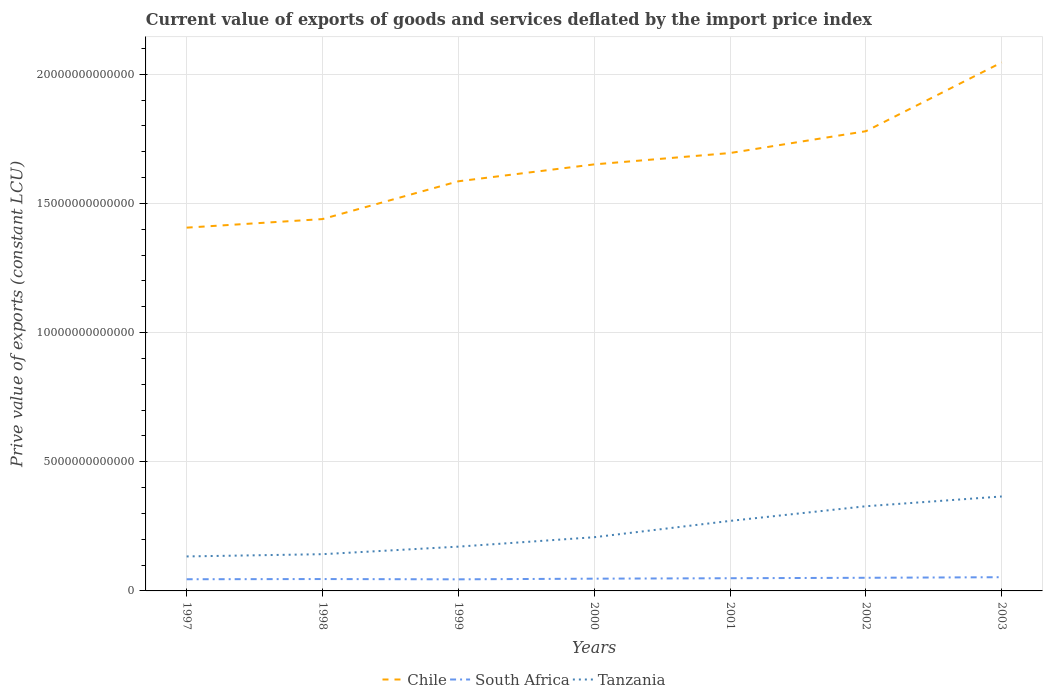Does the line corresponding to South Africa intersect with the line corresponding to Tanzania?
Your answer should be very brief. No. Across all years, what is the maximum prive value of exports in Chile?
Provide a succinct answer. 1.41e+13. In which year was the prive value of exports in South Africa maximum?
Make the answer very short. 1999. What is the total prive value of exports in Tanzania in the graph?
Your response must be concise. -1.86e+12. What is the difference between the highest and the second highest prive value of exports in Tanzania?
Your answer should be very brief. 2.32e+12. What is the difference between the highest and the lowest prive value of exports in Tanzania?
Offer a terse response. 3. Is the prive value of exports in Tanzania strictly greater than the prive value of exports in Chile over the years?
Give a very brief answer. Yes. What is the difference between two consecutive major ticks on the Y-axis?
Your answer should be compact. 5.00e+12. Does the graph contain any zero values?
Make the answer very short. No. Does the graph contain grids?
Provide a succinct answer. Yes. What is the title of the graph?
Your response must be concise. Current value of exports of goods and services deflated by the import price index. Does "South Africa" appear as one of the legend labels in the graph?
Make the answer very short. Yes. What is the label or title of the Y-axis?
Your answer should be very brief. Prive value of exports (constant LCU). What is the Prive value of exports (constant LCU) in Chile in 1997?
Your response must be concise. 1.41e+13. What is the Prive value of exports (constant LCU) of South Africa in 1997?
Give a very brief answer. 4.52e+11. What is the Prive value of exports (constant LCU) of Tanzania in 1997?
Keep it short and to the point. 1.34e+12. What is the Prive value of exports (constant LCU) of Chile in 1998?
Your answer should be compact. 1.44e+13. What is the Prive value of exports (constant LCU) in South Africa in 1998?
Your response must be concise. 4.60e+11. What is the Prive value of exports (constant LCU) in Tanzania in 1998?
Provide a succinct answer. 1.42e+12. What is the Prive value of exports (constant LCU) in Chile in 1999?
Offer a terse response. 1.59e+13. What is the Prive value of exports (constant LCU) of South Africa in 1999?
Offer a very short reply. 4.49e+11. What is the Prive value of exports (constant LCU) in Tanzania in 1999?
Your answer should be very brief. 1.71e+12. What is the Prive value of exports (constant LCU) of Chile in 2000?
Your answer should be compact. 1.65e+13. What is the Prive value of exports (constant LCU) in South Africa in 2000?
Ensure brevity in your answer.  4.75e+11. What is the Prive value of exports (constant LCU) in Tanzania in 2000?
Your answer should be compact. 2.08e+12. What is the Prive value of exports (constant LCU) in Chile in 2001?
Give a very brief answer. 1.70e+13. What is the Prive value of exports (constant LCU) in South Africa in 2001?
Ensure brevity in your answer.  4.91e+11. What is the Prive value of exports (constant LCU) in Tanzania in 2001?
Ensure brevity in your answer.  2.71e+12. What is the Prive value of exports (constant LCU) in Chile in 2002?
Make the answer very short. 1.78e+13. What is the Prive value of exports (constant LCU) of South Africa in 2002?
Make the answer very short. 5.09e+11. What is the Prive value of exports (constant LCU) in Tanzania in 2002?
Ensure brevity in your answer.  3.28e+12. What is the Prive value of exports (constant LCU) of Chile in 2003?
Provide a short and direct response. 2.05e+13. What is the Prive value of exports (constant LCU) in South Africa in 2003?
Offer a very short reply. 5.31e+11. What is the Prive value of exports (constant LCU) of Tanzania in 2003?
Your answer should be compact. 3.66e+12. Across all years, what is the maximum Prive value of exports (constant LCU) of Chile?
Make the answer very short. 2.05e+13. Across all years, what is the maximum Prive value of exports (constant LCU) in South Africa?
Ensure brevity in your answer.  5.31e+11. Across all years, what is the maximum Prive value of exports (constant LCU) in Tanzania?
Your answer should be compact. 3.66e+12. Across all years, what is the minimum Prive value of exports (constant LCU) of Chile?
Offer a very short reply. 1.41e+13. Across all years, what is the minimum Prive value of exports (constant LCU) in South Africa?
Provide a short and direct response. 4.49e+11. Across all years, what is the minimum Prive value of exports (constant LCU) of Tanzania?
Make the answer very short. 1.34e+12. What is the total Prive value of exports (constant LCU) in Chile in the graph?
Make the answer very short. 1.16e+14. What is the total Prive value of exports (constant LCU) of South Africa in the graph?
Provide a short and direct response. 3.37e+12. What is the total Prive value of exports (constant LCU) of Tanzania in the graph?
Offer a very short reply. 1.62e+13. What is the difference between the Prive value of exports (constant LCU) in Chile in 1997 and that in 1998?
Provide a short and direct response. -3.32e+11. What is the difference between the Prive value of exports (constant LCU) in South Africa in 1997 and that in 1998?
Offer a very short reply. -7.87e+09. What is the difference between the Prive value of exports (constant LCU) in Tanzania in 1997 and that in 1998?
Provide a short and direct response. -8.70e+1. What is the difference between the Prive value of exports (constant LCU) in Chile in 1997 and that in 1999?
Provide a succinct answer. -1.79e+12. What is the difference between the Prive value of exports (constant LCU) in South Africa in 1997 and that in 1999?
Keep it short and to the point. 3.42e+09. What is the difference between the Prive value of exports (constant LCU) in Tanzania in 1997 and that in 1999?
Your response must be concise. -3.79e+11. What is the difference between the Prive value of exports (constant LCU) in Chile in 1997 and that in 2000?
Make the answer very short. -2.45e+12. What is the difference between the Prive value of exports (constant LCU) in South Africa in 1997 and that in 2000?
Make the answer very short. -2.25e+1. What is the difference between the Prive value of exports (constant LCU) of Tanzania in 1997 and that in 2000?
Ensure brevity in your answer.  -7.44e+11. What is the difference between the Prive value of exports (constant LCU) in Chile in 1997 and that in 2001?
Ensure brevity in your answer.  -2.89e+12. What is the difference between the Prive value of exports (constant LCU) of South Africa in 1997 and that in 2001?
Make the answer very short. -3.92e+1. What is the difference between the Prive value of exports (constant LCU) in Tanzania in 1997 and that in 2001?
Ensure brevity in your answer.  -1.38e+12. What is the difference between the Prive value of exports (constant LCU) of Chile in 1997 and that in 2002?
Offer a terse response. -3.73e+12. What is the difference between the Prive value of exports (constant LCU) in South Africa in 1997 and that in 2002?
Your answer should be compact. -5.67e+1. What is the difference between the Prive value of exports (constant LCU) in Tanzania in 1997 and that in 2002?
Keep it short and to the point. -1.94e+12. What is the difference between the Prive value of exports (constant LCU) of Chile in 1997 and that in 2003?
Your answer should be very brief. -6.40e+12. What is the difference between the Prive value of exports (constant LCU) in South Africa in 1997 and that in 2003?
Ensure brevity in your answer.  -7.89e+1. What is the difference between the Prive value of exports (constant LCU) in Tanzania in 1997 and that in 2003?
Provide a succinct answer. -2.32e+12. What is the difference between the Prive value of exports (constant LCU) of Chile in 1998 and that in 1999?
Offer a very short reply. -1.46e+12. What is the difference between the Prive value of exports (constant LCU) in South Africa in 1998 and that in 1999?
Offer a very short reply. 1.13e+1. What is the difference between the Prive value of exports (constant LCU) in Tanzania in 1998 and that in 1999?
Your answer should be very brief. -2.92e+11. What is the difference between the Prive value of exports (constant LCU) of Chile in 1998 and that in 2000?
Your answer should be very brief. -2.12e+12. What is the difference between the Prive value of exports (constant LCU) of South Africa in 1998 and that in 2000?
Offer a terse response. -1.46e+1. What is the difference between the Prive value of exports (constant LCU) of Tanzania in 1998 and that in 2000?
Offer a very short reply. -6.57e+11. What is the difference between the Prive value of exports (constant LCU) in Chile in 1998 and that in 2001?
Provide a short and direct response. -2.56e+12. What is the difference between the Prive value of exports (constant LCU) in South Africa in 1998 and that in 2001?
Your response must be concise. -3.14e+1. What is the difference between the Prive value of exports (constant LCU) of Tanzania in 1998 and that in 2001?
Provide a succinct answer. -1.29e+12. What is the difference between the Prive value of exports (constant LCU) in Chile in 1998 and that in 2002?
Ensure brevity in your answer.  -3.40e+12. What is the difference between the Prive value of exports (constant LCU) of South Africa in 1998 and that in 2002?
Offer a very short reply. -4.88e+1. What is the difference between the Prive value of exports (constant LCU) in Tanzania in 1998 and that in 2002?
Your response must be concise. -1.86e+12. What is the difference between the Prive value of exports (constant LCU) of Chile in 1998 and that in 2003?
Ensure brevity in your answer.  -6.06e+12. What is the difference between the Prive value of exports (constant LCU) in South Africa in 1998 and that in 2003?
Provide a short and direct response. -7.10e+1. What is the difference between the Prive value of exports (constant LCU) in Tanzania in 1998 and that in 2003?
Ensure brevity in your answer.  -2.23e+12. What is the difference between the Prive value of exports (constant LCU) in Chile in 1999 and that in 2000?
Offer a very short reply. -6.54e+11. What is the difference between the Prive value of exports (constant LCU) of South Africa in 1999 and that in 2000?
Keep it short and to the point. -2.59e+1. What is the difference between the Prive value of exports (constant LCU) of Tanzania in 1999 and that in 2000?
Your answer should be compact. -3.65e+11. What is the difference between the Prive value of exports (constant LCU) of Chile in 1999 and that in 2001?
Provide a short and direct response. -1.09e+12. What is the difference between the Prive value of exports (constant LCU) in South Africa in 1999 and that in 2001?
Ensure brevity in your answer.  -4.26e+1. What is the difference between the Prive value of exports (constant LCU) in Tanzania in 1999 and that in 2001?
Your answer should be very brief. -9.97e+11. What is the difference between the Prive value of exports (constant LCU) of Chile in 1999 and that in 2002?
Ensure brevity in your answer.  -1.94e+12. What is the difference between the Prive value of exports (constant LCU) in South Africa in 1999 and that in 2002?
Your answer should be very brief. -6.01e+1. What is the difference between the Prive value of exports (constant LCU) in Tanzania in 1999 and that in 2002?
Provide a succinct answer. -1.56e+12. What is the difference between the Prive value of exports (constant LCU) in Chile in 1999 and that in 2003?
Give a very brief answer. -4.60e+12. What is the difference between the Prive value of exports (constant LCU) of South Africa in 1999 and that in 2003?
Give a very brief answer. -8.23e+1. What is the difference between the Prive value of exports (constant LCU) of Tanzania in 1999 and that in 2003?
Offer a terse response. -1.94e+12. What is the difference between the Prive value of exports (constant LCU) of Chile in 2000 and that in 2001?
Make the answer very short. -4.39e+11. What is the difference between the Prive value of exports (constant LCU) in South Africa in 2000 and that in 2001?
Your response must be concise. -1.68e+1. What is the difference between the Prive value of exports (constant LCU) of Tanzania in 2000 and that in 2001?
Your answer should be compact. -6.32e+11. What is the difference between the Prive value of exports (constant LCU) of Chile in 2000 and that in 2002?
Your response must be concise. -1.28e+12. What is the difference between the Prive value of exports (constant LCU) of South Africa in 2000 and that in 2002?
Make the answer very short. -3.42e+1. What is the difference between the Prive value of exports (constant LCU) of Tanzania in 2000 and that in 2002?
Offer a terse response. -1.20e+12. What is the difference between the Prive value of exports (constant LCU) in Chile in 2000 and that in 2003?
Your answer should be very brief. -3.95e+12. What is the difference between the Prive value of exports (constant LCU) of South Africa in 2000 and that in 2003?
Your response must be concise. -5.64e+1. What is the difference between the Prive value of exports (constant LCU) in Tanzania in 2000 and that in 2003?
Your response must be concise. -1.58e+12. What is the difference between the Prive value of exports (constant LCU) of Chile in 2001 and that in 2002?
Your answer should be compact. -8.45e+11. What is the difference between the Prive value of exports (constant LCU) in South Africa in 2001 and that in 2002?
Make the answer very short. -1.75e+1. What is the difference between the Prive value of exports (constant LCU) of Tanzania in 2001 and that in 2002?
Your response must be concise. -5.68e+11. What is the difference between the Prive value of exports (constant LCU) in Chile in 2001 and that in 2003?
Provide a succinct answer. -3.51e+12. What is the difference between the Prive value of exports (constant LCU) of South Africa in 2001 and that in 2003?
Your answer should be compact. -3.97e+1. What is the difference between the Prive value of exports (constant LCU) in Tanzania in 2001 and that in 2003?
Offer a terse response. -9.46e+11. What is the difference between the Prive value of exports (constant LCU) in Chile in 2002 and that in 2003?
Offer a very short reply. -2.66e+12. What is the difference between the Prive value of exports (constant LCU) of South Africa in 2002 and that in 2003?
Your answer should be very brief. -2.22e+1. What is the difference between the Prive value of exports (constant LCU) of Tanzania in 2002 and that in 2003?
Keep it short and to the point. -3.78e+11. What is the difference between the Prive value of exports (constant LCU) of Chile in 1997 and the Prive value of exports (constant LCU) of South Africa in 1998?
Provide a short and direct response. 1.36e+13. What is the difference between the Prive value of exports (constant LCU) of Chile in 1997 and the Prive value of exports (constant LCU) of Tanzania in 1998?
Ensure brevity in your answer.  1.26e+13. What is the difference between the Prive value of exports (constant LCU) in South Africa in 1997 and the Prive value of exports (constant LCU) in Tanzania in 1998?
Your response must be concise. -9.70e+11. What is the difference between the Prive value of exports (constant LCU) of Chile in 1997 and the Prive value of exports (constant LCU) of South Africa in 1999?
Keep it short and to the point. 1.36e+13. What is the difference between the Prive value of exports (constant LCU) in Chile in 1997 and the Prive value of exports (constant LCU) in Tanzania in 1999?
Make the answer very short. 1.23e+13. What is the difference between the Prive value of exports (constant LCU) in South Africa in 1997 and the Prive value of exports (constant LCU) in Tanzania in 1999?
Your answer should be compact. -1.26e+12. What is the difference between the Prive value of exports (constant LCU) in Chile in 1997 and the Prive value of exports (constant LCU) in South Africa in 2000?
Ensure brevity in your answer.  1.36e+13. What is the difference between the Prive value of exports (constant LCU) of Chile in 1997 and the Prive value of exports (constant LCU) of Tanzania in 2000?
Make the answer very short. 1.20e+13. What is the difference between the Prive value of exports (constant LCU) in South Africa in 1997 and the Prive value of exports (constant LCU) in Tanzania in 2000?
Give a very brief answer. -1.63e+12. What is the difference between the Prive value of exports (constant LCU) in Chile in 1997 and the Prive value of exports (constant LCU) in South Africa in 2001?
Offer a terse response. 1.36e+13. What is the difference between the Prive value of exports (constant LCU) in Chile in 1997 and the Prive value of exports (constant LCU) in Tanzania in 2001?
Provide a succinct answer. 1.14e+13. What is the difference between the Prive value of exports (constant LCU) in South Africa in 1997 and the Prive value of exports (constant LCU) in Tanzania in 2001?
Your answer should be compact. -2.26e+12. What is the difference between the Prive value of exports (constant LCU) in Chile in 1997 and the Prive value of exports (constant LCU) in South Africa in 2002?
Your answer should be very brief. 1.36e+13. What is the difference between the Prive value of exports (constant LCU) in Chile in 1997 and the Prive value of exports (constant LCU) in Tanzania in 2002?
Ensure brevity in your answer.  1.08e+13. What is the difference between the Prive value of exports (constant LCU) of South Africa in 1997 and the Prive value of exports (constant LCU) of Tanzania in 2002?
Your answer should be compact. -2.83e+12. What is the difference between the Prive value of exports (constant LCU) in Chile in 1997 and the Prive value of exports (constant LCU) in South Africa in 2003?
Keep it short and to the point. 1.35e+13. What is the difference between the Prive value of exports (constant LCU) in Chile in 1997 and the Prive value of exports (constant LCU) in Tanzania in 2003?
Make the answer very short. 1.04e+13. What is the difference between the Prive value of exports (constant LCU) of South Africa in 1997 and the Prive value of exports (constant LCU) of Tanzania in 2003?
Make the answer very short. -3.20e+12. What is the difference between the Prive value of exports (constant LCU) of Chile in 1998 and the Prive value of exports (constant LCU) of South Africa in 1999?
Make the answer very short. 1.39e+13. What is the difference between the Prive value of exports (constant LCU) in Chile in 1998 and the Prive value of exports (constant LCU) in Tanzania in 1999?
Offer a very short reply. 1.27e+13. What is the difference between the Prive value of exports (constant LCU) of South Africa in 1998 and the Prive value of exports (constant LCU) of Tanzania in 1999?
Make the answer very short. -1.25e+12. What is the difference between the Prive value of exports (constant LCU) of Chile in 1998 and the Prive value of exports (constant LCU) of South Africa in 2000?
Your response must be concise. 1.39e+13. What is the difference between the Prive value of exports (constant LCU) in Chile in 1998 and the Prive value of exports (constant LCU) in Tanzania in 2000?
Offer a very short reply. 1.23e+13. What is the difference between the Prive value of exports (constant LCU) of South Africa in 1998 and the Prive value of exports (constant LCU) of Tanzania in 2000?
Your answer should be compact. -1.62e+12. What is the difference between the Prive value of exports (constant LCU) in Chile in 1998 and the Prive value of exports (constant LCU) in South Africa in 2001?
Give a very brief answer. 1.39e+13. What is the difference between the Prive value of exports (constant LCU) of Chile in 1998 and the Prive value of exports (constant LCU) of Tanzania in 2001?
Provide a short and direct response. 1.17e+13. What is the difference between the Prive value of exports (constant LCU) in South Africa in 1998 and the Prive value of exports (constant LCU) in Tanzania in 2001?
Give a very brief answer. -2.25e+12. What is the difference between the Prive value of exports (constant LCU) of Chile in 1998 and the Prive value of exports (constant LCU) of South Africa in 2002?
Offer a very short reply. 1.39e+13. What is the difference between the Prive value of exports (constant LCU) in Chile in 1998 and the Prive value of exports (constant LCU) in Tanzania in 2002?
Your answer should be very brief. 1.11e+13. What is the difference between the Prive value of exports (constant LCU) in South Africa in 1998 and the Prive value of exports (constant LCU) in Tanzania in 2002?
Provide a succinct answer. -2.82e+12. What is the difference between the Prive value of exports (constant LCU) in Chile in 1998 and the Prive value of exports (constant LCU) in South Africa in 2003?
Your answer should be compact. 1.39e+13. What is the difference between the Prive value of exports (constant LCU) of Chile in 1998 and the Prive value of exports (constant LCU) of Tanzania in 2003?
Provide a short and direct response. 1.07e+13. What is the difference between the Prive value of exports (constant LCU) in South Africa in 1998 and the Prive value of exports (constant LCU) in Tanzania in 2003?
Make the answer very short. -3.20e+12. What is the difference between the Prive value of exports (constant LCU) in Chile in 1999 and the Prive value of exports (constant LCU) in South Africa in 2000?
Your answer should be very brief. 1.54e+13. What is the difference between the Prive value of exports (constant LCU) of Chile in 1999 and the Prive value of exports (constant LCU) of Tanzania in 2000?
Keep it short and to the point. 1.38e+13. What is the difference between the Prive value of exports (constant LCU) in South Africa in 1999 and the Prive value of exports (constant LCU) in Tanzania in 2000?
Ensure brevity in your answer.  -1.63e+12. What is the difference between the Prive value of exports (constant LCU) of Chile in 1999 and the Prive value of exports (constant LCU) of South Africa in 2001?
Provide a succinct answer. 1.54e+13. What is the difference between the Prive value of exports (constant LCU) of Chile in 1999 and the Prive value of exports (constant LCU) of Tanzania in 2001?
Provide a short and direct response. 1.31e+13. What is the difference between the Prive value of exports (constant LCU) of South Africa in 1999 and the Prive value of exports (constant LCU) of Tanzania in 2001?
Your answer should be compact. -2.26e+12. What is the difference between the Prive value of exports (constant LCU) of Chile in 1999 and the Prive value of exports (constant LCU) of South Africa in 2002?
Keep it short and to the point. 1.53e+13. What is the difference between the Prive value of exports (constant LCU) of Chile in 1999 and the Prive value of exports (constant LCU) of Tanzania in 2002?
Your response must be concise. 1.26e+13. What is the difference between the Prive value of exports (constant LCU) in South Africa in 1999 and the Prive value of exports (constant LCU) in Tanzania in 2002?
Offer a very short reply. -2.83e+12. What is the difference between the Prive value of exports (constant LCU) of Chile in 1999 and the Prive value of exports (constant LCU) of South Africa in 2003?
Keep it short and to the point. 1.53e+13. What is the difference between the Prive value of exports (constant LCU) in Chile in 1999 and the Prive value of exports (constant LCU) in Tanzania in 2003?
Offer a terse response. 1.22e+13. What is the difference between the Prive value of exports (constant LCU) in South Africa in 1999 and the Prive value of exports (constant LCU) in Tanzania in 2003?
Provide a succinct answer. -3.21e+12. What is the difference between the Prive value of exports (constant LCU) of Chile in 2000 and the Prive value of exports (constant LCU) of South Africa in 2001?
Provide a succinct answer. 1.60e+13. What is the difference between the Prive value of exports (constant LCU) of Chile in 2000 and the Prive value of exports (constant LCU) of Tanzania in 2001?
Offer a very short reply. 1.38e+13. What is the difference between the Prive value of exports (constant LCU) in South Africa in 2000 and the Prive value of exports (constant LCU) in Tanzania in 2001?
Give a very brief answer. -2.24e+12. What is the difference between the Prive value of exports (constant LCU) in Chile in 2000 and the Prive value of exports (constant LCU) in South Africa in 2002?
Your answer should be compact. 1.60e+13. What is the difference between the Prive value of exports (constant LCU) of Chile in 2000 and the Prive value of exports (constant LCU) of Tanzania in 2002?
Your answer should be very brief. 1.32e+13. What is the difference between the Prive value of exports (constant LCU) in South Africa in 2000 and the Prive value of exports (constant LCU) in Tanzania in 2002?
Offer a terse response. -2.80e+12. What is the difference between the Prive value of exports (constant LCU) of Chile in 2000 and the Prive value of exports (constant LCU) of South Africa in 2003?
Provide a succinct answer. 1.60e+13. What is the difference between the Prive value of exports (constant LCU) in Chile in 2000 and the Prive value of exports (constant LCU) in Tanzania in 2003?
Make the answer very short. 1.29e+13. What is the difference between the Prive value of exports (constant LCU) of South Africa in 2000 and the Prive value of exports (constant LCU) of Tanzania in 2003?
Make the answer very short. -3.18e+12. What is the difference between the Prive value of exports (constant LCU) of Chile in 2001 and the Prive value of exports (constant LCU) of South Africa in 2002?
Your answer should be compact. 1.64e+13. What is the difference between the Prive value of exports (constant LCU) of Chile in 2001 and the Prive value of exports (constant LCU) of Tanzania in 2002?
Ensure brevity in your answer.  1.37e+13. What is the difference between the Prive value of exports (constant LCU) of South Africa in 2001 and the Prive value of exports (constant LCU) of Tanzania in 2002?
Ensure brevity in your answer.  -2.79e+12. What is the difference between the Prive value of exports (constant LCU) of Chile in 2001 and the Prive value of exports (constant LCU) of South Africa in 2003?
Provide a short and direct response. 1.64e+13. What is the difference between the Prive value of exports (constant LCU) of Chile in 2001 and the Prive value of exports (constant LCU) of Tanzania in 2003?
Your answer should be compact. 1.33e+13. What is the difference between the Prive value of exports (constant LCU) in South Africa in 2001 and the Prive value of exports (constant LCU) in Tanzania in 2003?
Your response must be concise. -3.17e+12. What is the difference between the Prive value of exports (constant LCU) in Chile in 2002 and the Prive value of exports (constant LCU) in South Africa in 2003?
Offer a very short reply. 1.73e+13. What is the difference between the Prive value of exports (constant LCU) of Chile in 2002 and the Prive value of exports (constant LCU) of Tanzania in 2003?
Provide a succinct answer. 1.41e+13. What is the difference between the Prive value of exports (constant LCU) in South Africa in 2002 and the Prive value of exports (constant LCU) in Tanzania in 2003?
Provide a succinct answer. -3.15e+12. What is the average Prive value of exports (constant LCU) of Chile per year?
Keep it short and to the point. 1.66e+13. What is the average Prive value of exports (constant LCU) in South Africa per year?
Make the answer very short. 4.81e+11. What is the average Prive value of exports (constant LCU) in Tanzania per year?
Ensure brevity in your answer.  2.31e+12. In the year 1997, what is the difference between the Prive value of exports (constant LCU) of Chile and Prive value of exports (constant LCU) of South Africa?
Keep it short and to the point. 1.36e+13. In the year 1997, what is the difference between the Prive value of exports (constant LCU) in Chile and Prive value of exports (constant LCU) in Tanzania?
Give a very brief answer. 1.27e+13. In the year 1997, what is the difference between the Prive value of exports (constant LCU) of South Africa and Prive value of exports (constant LCU) of Tanzania?
Provide a succinct answer. -8.83e+11. In the year 1998, what is the difference between the Prive value of exports (constant LCU) in Chile and Prive value of exports (constant LCU) in South Africa?
Make the answer very short. 1.39e+13. In the year 1998, what is the difference between the Prive value of exports (constant LCU) in Chile and Prive value of exports (constant LCU) in Tanzania?
Offer a terse response. 1.30e+13. In the year 1998, what is the difference between the Prive value of exports (constant LCU) of South Africa and Prive value of exports (constant LCU) of Tanzania?
Give a very brief answer. -9.62e+11. In the year 1999, what is the difference between the Prive value of exports (constant LCU) in Chile and Prive value of exports (constant LCU) in South Africa?
Your response must be concise. 1.54e+13. In the year 1999, what is the difference between the Prive value of exports (constant LCU) of Chile and Prive value of exports (constant LCU) of Tanzania?
Your response must be concise. 1.41e+13. In the year 1999, what is the difference between the Prive value of exports (constant LCU) in South Africa and Prive value of exports (constant LCU) in Tanzania?
Your answer should be very brief. -1.27e+12. In the year 2000, what is the difference between the Prive value of exports (constant LCU) in Chile and Prive value of exports (constant LCU) in South Africa?
Provide a short and direct response. 1.60e+13. In the year 2000, what is the difference between the Prive value of exports (constant LCU) of Chile and Prive value of exports (constant LCU) of Tanzania?
Make the answer very short. 1.44e+13. In the year 2000, what is the difference between the Prive value of exports (constant LCU) in South Africa and Prive value of exports (constant LCU) in Tanzania?
Your answer should be very brief. -1.60e+12. In the year 2001, what is the difference between the Prive value of exports (constant LCU) in Chile and Prive value of exports (constant LCU) in South Africa?
Your answer should be very brief. 1.65e+13. In the year 2001, what is the difference between the Prive value of exports (constant LCU) in Chile and Prive value of exports (constant LCU) in Tanzania?
Ensure brevity in your answer.  1.42e+13. In the year 2001, what is the difference between the Prive value of exports (constant LCU) in South Africa and Prive value of exports (constant LCU) in Tanzania?
Provide a short and direct response. -2.22e+12. In the year 2002, what is the difference between the Prive value of exports (constant LCU) of Chile and Prive value of exports (constant LCU) of South Africa?
Offer a very short reply. 1.73e+13. In the year 2002, what is the difference between the Prive value of exports (constant LCU) in Chile and Prive value of exports (constant LCU) in Tanzania?
Offer a very short reply. 1.45e+13. In the year 2002, what is the difference between the Prive value of exports (constant LCU) in South Africa and Prive value of exports (constant LCU) in Tanzania?
Provide a succinct answer. -2.77e+12. In the year 2003, what is the difference between the Prive value of exports (constant LCU) of Chile and Prive value of exports (constant LCU) of South Africa?
Your answer should be very brief. 1.99e+13. In the year 2003, what is the difference between the Prive value of exports (constant LCU) of Chile and Prive value of exports (constant LCU) of Tanzania?
Make the answer very short. 1.68e+13. In the year 2003, what is the difference between the Prive value of exports (constant LCU) in South Africa and Prive value of exports (constant LCU) in Tanzania?
Provide a short and direct response. -3.13e+12. What is the ratio of the Prive value of exports (constant LCU) of Chile in 1997 to that in 1998?
Your response must be concise. 0.98. What is the ratio of the Prive value of exports (constant LCU) in South Africa in 1997 to that in 1998?
Your answer should be compact. 0.98. What is the ratio of the Prive value of exports (constant LCU) of Tanzania in 1997 to that in 1998?
Your answer should be very brief. 0.94. What is the ratio of the Prive value of exports (constant LCU) of Chile in 1997 to that in 1999?
Give a very brief answer. 0.89. What is the ratio of the Prive value of exports (constant LCU) in South Africa in 1997 to that in 1999?
Provide a short and direct response. 1.01. What is the ratio of the Prive value of exports (constant LCU) of Tanzania in 1997 to that in 1999?
Keep it short and to the point. 0.78. What is the ratio of the Prive value of exports (constant LCU) in Chile in 1997 to that in 2000?
Your answer should be compact. 0.85. What is the ratio of the Prive value of exports (constant LCU) in South Africa in 1997 to that in 2000?
Ensure brevity in your answer.  0.95. What is the ratio of the Prive value of exports (constant LCU) of Tanzania in 1997 to that in 2000?
Offer a terse response. 0.64. What is the ratio of the Prive value of exports (constant LCU) of Chile in 1997 to that in 2001?
Your response must be concise. 0.83. What is the ratio of the Prive value of exports (constant LCU) in South Africa in 1997 to that in 2001?
Offer a very short reply. 0.92. What is the ratio of the Prive value of exports (constant LCU) in Tanzania in 1997 to that in 2001?
Provide a succinct answer. 0.49. What is the ratio of the Prive value of exports (constant LCU) of Chile in 1997 to that in 2002?
Make the answer very short. 0.79. What is the ratio of the Prive value of exports (constant LCU) in South Africa in 1997 to that in 2002?
Offer a terse response. 0.89. What is the ratio of the Prive value of exports (constant LCU) in Tanzania in 1997 to that in 2002?
Your answer should be compact. 0.41. What is the ratio of the Prive value of exports (constant LCU) of Chile in 1997 to that in 2003?
Make the answer very short. 0.69. What is the ratio of the Prive value of exports (constant LCU) in South Africa in 1997 to that in 2003?
Provide a short and direct response. 0.85. What is the ratio of the Prive value of exports (constant LCU) of Tanzania in 1997 to that in 2003?
Provide a succinct answer. 0.37. What is the ratio of the Prive value of exports (constant LCU) of Chile in 1998 to that in 1999?
Your response must be concise. 0.91. What is the ratio of the Prive value of exports (constant LCU) of South Africa in 1998 to that in 1999?
Make the answer very short. 1.03. What is the ratio of the Prive value of exports (constant LCU) in Tanzania in 1998 to that in 1999?
Offer a very short reply. 0.83. What is the ratio of the Prive value of exports (constant LCU) in Chile in 1998 to that in 2000?
Make the answer very short. 0.87. What is the ratio of the Prive value of exports (constant LCU) of South Africa in 1998 to that in 2000?
Your answer should be compact. 0.97. What is the ratio of the Prive value of exports (constant LCU) in Tanzania in 1998 to that in 2000?
Keep it short and to the point. 0.68. What is the ratio of the Prive value of exports (constant LCU) of Chile in 1998 to that in 2001?
Your answer should be very brief. 0.85. What is the ratio of the Prive value of exports (constant LCU) of South Africa in 1998 to that in 2001?
Ensure brevity in your answer.  0.94. What is the ratio of the Prive value of exports (constant LCU) in Tanzania in 1998 to that in 2001?
Provide a short and direct response. 0.52. What is the ratio of the Prive value of exports (constant LCU) of Chile in 1998 to that in 2002?
Keep it short and to the point. 0.81. What is the ratio of the Prive value of exports (constant LCU) of South Africa in 1998 to that in 2002?
Provide a succinct answer. 0.9. What is the ratio of the Prive value of exports (constant LCU) of Tanzania in 1998 to that in 2002?
Offer a very short reply. 0.43. What is the ratio of the Prive value of exports (constant LCU) of Chile in 1998 to that in 2003?
Offer a terse response. 0.7. What is the ratio of the Prive value of exports (constant LCU) in South Africa in 1998 to that in 2003?
Give a very brief answer. 0.87. What is the ratio of the Prive value of exports (constant LCU) in Tanzania in 1998 to that in 2003?
Offer a very short reply. 0.39. What is the ratio of the Prive value of exports (constant LCU) in Chile in 1999 to that in 2000?
Your answer should be compact. 0.96. What is the ratio of the Prive value of exports (constant LCU) in South Africa in 1999 to that in 2000?
Provide a short and direct response. 0.95. What is the ratio of the Prive value of exports (constant LCU) of Tanzania in 1999 to that in 2000?
Keep it short and to the point. 0.82. What is the ratio of the Prive value of exports (constant LCU) in Chile in 1999 to that in 2001?
Your response must be concise. 0.94. What is the ratio of the Prive value of exports (constant LCU) of South Africa in 1999 to that in 2001?
Your answer should be very brief. 0.91. What is the ratio of the Prive value of exports (constant LCU) in Tanzania in 1999 to that in 2001?
Make the answer very short. 0.63. What is the ratio of the Prive value of exports (constant LCU) of Chile in 1999 to that in 2002?
Your answer should be compact. 0.89. What is the ratio of the Prive value of exports (constant LCU) in South Africa in 1999 to that in 2002?
Ensure brevity in your answer.  0.88. What is the ratio of the Prive value of exports (constant LCU) in Tanzania in 1999 to that in 2002?
Your answer should be compact. 0.52. What is the ratio of the Prive value of exports (constant LCU) in Chile in 1999 to that in 2003?
Keep it short and to the point. 0.78. What is the ratio of the Prive value of exports (constant LCU) in South Africa in 1999 to that in 2003?
Offer a very short reply. 0.84. What is the ratio of the Prive value of exports (constant LCU) in Tanzania in 1999 to that in 2003?
Give a very brief answer. 0.47. What is the ratio of the Prive value of exports (constant LCU) of Chile in 2000 to that in 2001?
Your response must be concise. 0.97. What is the ratio of the Prive value of exports (constant LCU) of South Africa in 2000 to that in 2001?
Your answer should be very brief. 0.97. What is the ratio of the Prive value of exports (constant LCU) in Tanzania in 2000 to that in 2001?
Offer a terse response. 0.77. What is the ratio of the Prive value of exports (constant LCU) in Chile in 2000 to that in 2002?
Keep it short and to the point. 0.93. What is the ratio of the Prive value of exports (constant LCU) in South Africa in 2000 to that in 2002?
Your response must be concise. 0.93. What is the ratio of the Prive value of exports (constant LCU) of Tanzania in 2000 to that in 2002?
Provide a succinct answer. 0.63. What is the ratio of the Prive value of exports (constant LCU) in Chile in 2000 to that in 2003?
Your answer should be very brief. 0.81. What is the ratio of the Prive value of exports (constant LCU) of South Africa in 2000 to that in 2003?
Offer a terse response. 0.89. What is the ratio of the Prive value of exports (constant LCU) in Tanzania in 2000 to that in 2003?
Give a very brief answer. 0.57. What is the ratio of the Prive value of exports (constant LCU) in Chile in 2001 to that in 2002?
Offer a very short reply. 0.95. What is the ratio of the Prive value of exports (constant LCU) of South Africa in 2001 to that in 2002?
Your answer should be very brief. 0.97. What is the ratio of the Prive value of exports (constant LCU) of Tanzania in 2001 to that in 2002?
Your answer should be very brief. 0.83. What is the ratio of the Prive value of exports (constant LCU) of Chile in 2001 to that in 2003?
Ensure brevity in your answer.  0.83. What is the ratio of the Prive value of exports (constant LCU) in South Africa in 2001 to that in 2003?
Give a very brief answer. 0.93. What is the ratio of the Prive value of exports (constant LCU) in Tanzania in 2001 to that in 2003?
Your answer should be very brief. 0.74. What is the ratio of the Prive value of exports (constant LCU) of Chile in 2002 to that in 2003?
Ensure brevity in your answer.  0.87. What is the ratio of the Prive value of exports (constant LCU) of South Africa in 2002 to that in 2003?
Provide a short and direct response. 0.96. What is the ratio of the Prive value of exports (constant LCU) of Tanzania in 2002 to that in 2003?
Offer a terse response. 0.9. What is the difference between the highest and the second highest Prive value of exports (constant LCU) in Chile?
Your answer should be very brief. 2.66e+12. What is the difference between the highest and the second highest Prive value of exports (constant LCU) in South Africa?
Your answer should be compact. 2.22e+1. What is the difference between the highest and the second highest Prive value of exports (constant LCU) in Tanzania?
Keep it short and to the point. 3.78e+11. What is the difference between the highest and the lowest Prive value of exports (constant LCU) in Chile?
Your response must be concise. 6.40e+12. What is the difference between the highest and the lowest Prive value of exports (constant LCU) in South Africa?
Provide a succinct answer. 8.23e+1. What is the difference between the highest and the lowest Prive value of exports (constant LCU) in Tanzania?
Provide a succinct answer. 2.32e+12. 